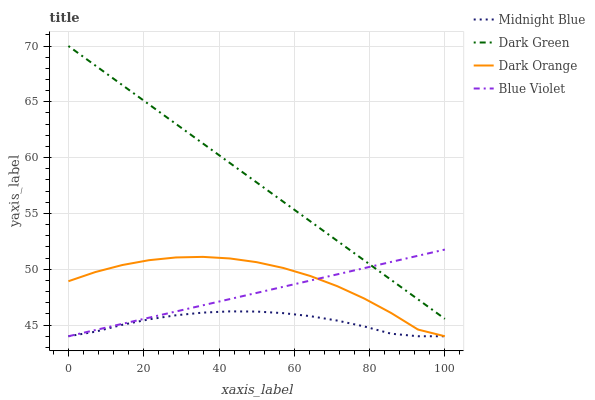Does Midnight Blue have the minimum area under the curve?
Answer yes or no. Yes. Does Dark Green have the maximum area under the curve?
Answer yes or no. Yes. Does Blue Violet have the minimum area under the curve?
Answer yes or no. No. Does Blue Violet have the maximum area under the curve?
Answer yes or no. No. Is Dark Green the smoothest?
Answer yes or no. Yes. Is Dark Orange the roughest?
Answer yes or no. Yes. Is Midnight Blue the smoothest?
Answer yes or no. No. Is Midnight Blue the roughest?
Answer yes or no. No. Does Dark Orange have the lowest value?
Answer yes or no. Yes. Does Dark Green have the lowest value?
Answer yes or no. No. Does Dark Green have the highest value?
Answer yes or no. Yes. Does Blue Violet have the highest value?
Answer yes or no. No. Is Dark Orange less than Dark Green?
Answer yes or no. Yes. Is Dark Green greater than Dark Orange?
Answer yes or no. Yes. Does Blue Violet intersect Midnight Blue?
Answer yes or no. Yes. Is Blue Violet less than Midnight Blue?
Answer yes or no. No. Is Blue Violet greater than Midnight Blue?
Answer yes or no. No. Does Dark Orange intersect Dark Green?
Answer yes or no. No. 